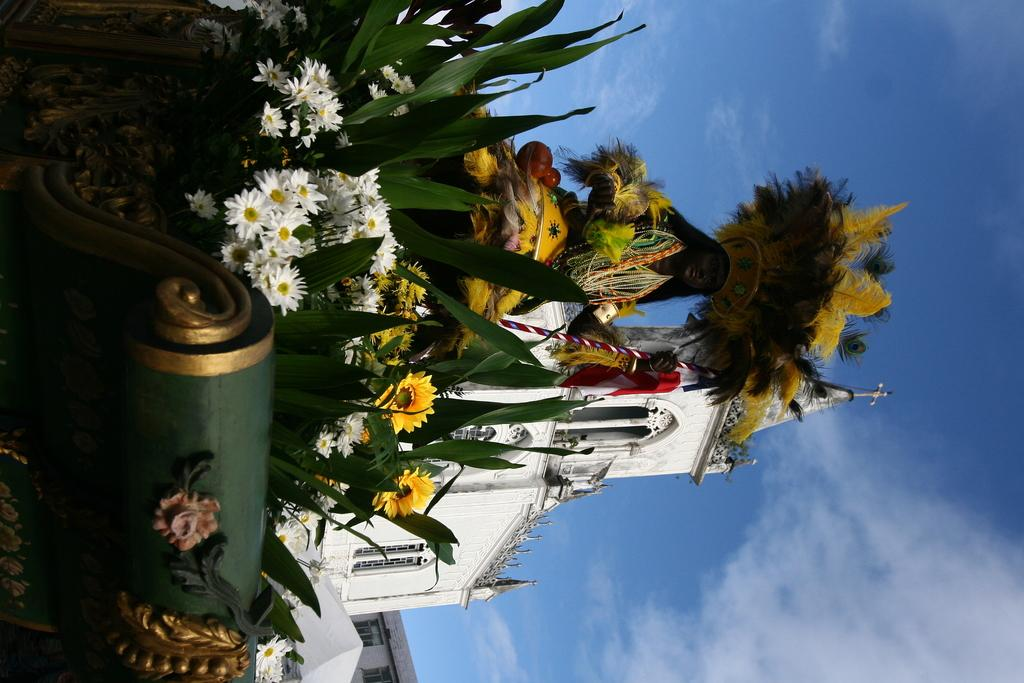What is the person in the image doing? The person is standing on a cart. How is the cart decorated? The cart is decorated with flowers and leaves. What can be seen in the background of the image? There is a church building in the background of the image. How many plates are being used by the person on the cart? There is no plate visible in the image, and the person is not using any plates. 